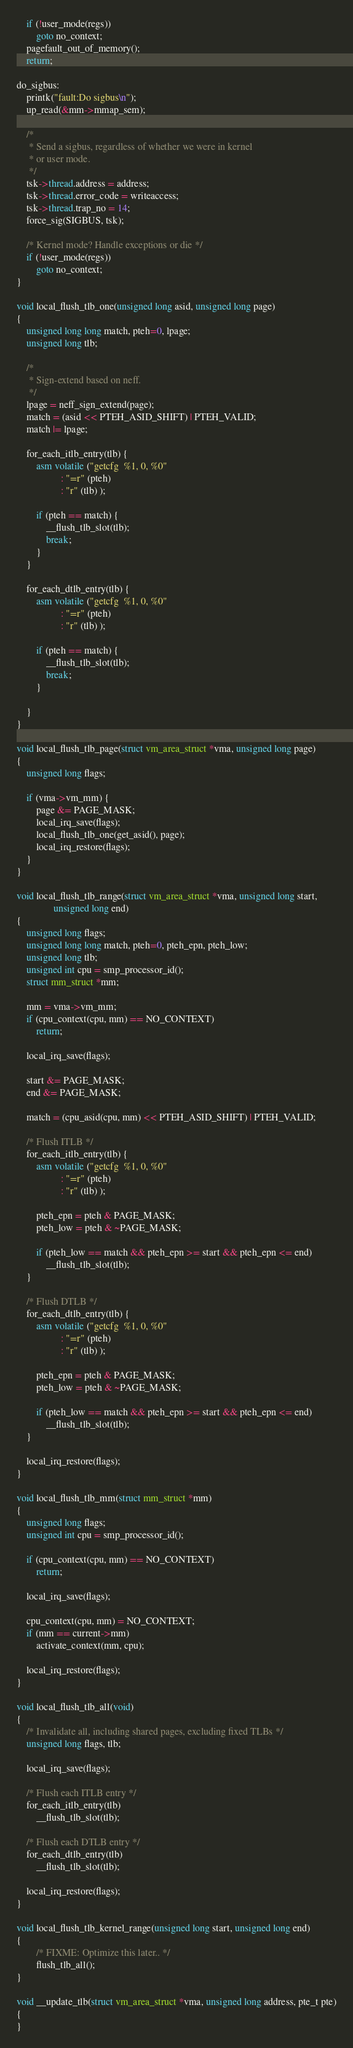<code> <loc_0><loc_0><loc_500><loc_500><_C_>	if (!user_mode(regs))
		goto no_context;
	pagefault_out_of_memory();
	return;

do_sigbus:
	printk("fault:Do sigbus\n");
	up_read(&mm->mmap_sem);

	/*
	 * Send a sigbus, regardless of whether we were in kernel
	 * or user mode.
	 */
	tsk->thread.address = address;
	tsk->thread.error_code = writeaccess;
	tsk->thread.trap_no = 14;
	force_sig(SIGBUS, tsk);

	/* Kernel mode? Handle exceptions or die */
	if (!user_mode(regs))
		goto no_context;
}

void local_flush_tlb_one(unsigned long asid, unsigned long page)
{
	unsigned long long match, pteh=0, lpage;
	unsigned long tlb;

	/*
	 * Sign-extend based on neff.
	 */
	lpage = neff_sign_extend(page);
	match = (asid << PTEH_ASID_SHIFT) | PTEH_VALID;
	match |= lpage;

	for_each_itlb_entry(tlb) {
		asm volatile ("getcfg	%1, 0, %0"
			      : "=r" (pteh)
			      : "r" (tlb) );

		if (pteh == match) {
			__flush_tlb_slot(tlb);
			break;
		}
	}

	for_each_dtlb_entry(tlb) {
		asm volatile ("getcfg	%1, 0, %0"
			      : "=r" (pteh)
			      : "r" (tlb) );

		if (pteh == match) {
			__flush_tlb_slot(tlb);
			break;
		}

	}
}

void local_flush_tlb_page(struct vm_area_struct *vma, unsigned long page)
{
	unsigned long flags;

	if (vma->vm_mm) {
		page &= PAGE_MASK;
		local_irq_save(flags);
		local_flush_tlb_one(get_asid(), page);
		local_irq_restore(flags);
	}
}

void local_flush_tlb_range(struct vm_area_struct *vma, unsigned long start,
			   unsigned long end)
{
	unsigned long flags;
	unsigned long long match, pteh=0, pteh_epn, pteh_low;
	unsigned long tlb;
	unsigned int cpu = smp_processor_id();
	struct mm_struct *mm;

	mm = vma->vm_mm;
	if (cpu_context(cpu, mm) == NO_CONTEXT)
		return;

	local_irq_save(flags);

	start &= PAGE_MASK;
	end &= PAGE_MASK;

	match = (cpu_asid(cpu, mm) << PTEH_ASID_SHIFT) | PTEH_VALID;

	/* Flush ITLB */
	for_each_itlb_entry(tlb) {
		asm volatile ("getcfg	%1, 0, %0"
			      : "=r" (pteh)
			      : "r" (tlb) );

		pteh_epn = pteh & PAGE_MASK;
		pteh_low = pteh & ~PAGE_MASK;

		if (pteh_low == match && pteh_epn >= start && pteh_epn <= end)
			__flush_tlb_slot(tlb);
	}

	/* Flush DTLB */
	for_each_dtlb_entry(tlb) {
		asm volatile ("getcfg	%1, 0, %0"
			      : "=r" (pteh)
			      : "r" (tlb) );

		pteh_epn = pteh & PAGE_MASK;
		pteh_low = pteh & ~PAGE_MASK;

		if (pteh_low == match && pteh_epn >= start && pteh_epn <= end)
			__flush_tlb_slot(tlb);
	}

	local_irq_restore(flags);
}

void local_flush_tlb_mm(struct mm_struct *mm)
{
	unsigned long flags;
	unsigned int cpu = smp_processor_id();

	if (cpu_context(cpu, mm) == NO_CONTEXT)
		return;

	local_irq_save(flags);

	cpu_context(cpu, mm) = NO_CONTEXT;
	if (mm == current->mm)
		activate_context(mm, cpu);

	local_irq_restore(flags);
}

void local_flush_tlb_all(void)
{
	/* Invalidate all, including shared pages, excluding fixed TLBs */
	unsigned long flags, tlb;

	local_irq_save(flags);

	/* Flush each ITLB entry */
	for_each_itlb_entry(tlb)
		__flush_tlb_slot(tlb);

	/* Flush each DTLB entry */
	for_each_dtlb_entry(tlb)
		__flush_tlb_slot(tlb);

	local_irq_restore(flags);
}

void local_flush_tlb_kernel_range(unsigned long start, unsigned long end)
{
        /* FIXME: Optimize this later.. */
        flush_tlb_all();
}

void __update_tlb(struct vm_area_struct *vma, unsigned long address, pte_t pte)
{
}
</code> 